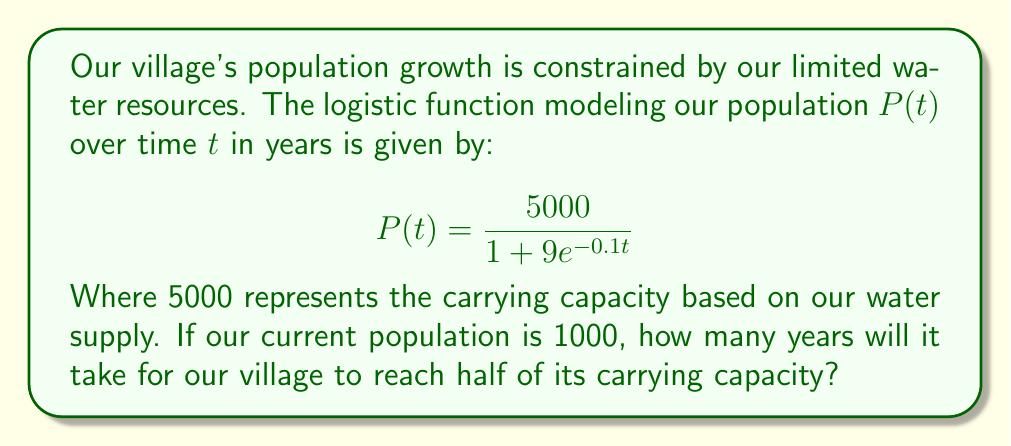Can you solve this math problem? 1) The carrying capacity is 5000, so we want to find when $P(t) = 2500$.

2) Set up the equation:
   $$2500 = \frac{5000}{1 + 9e^{-0.1t}}$$

3) Multiply both sides by $(1 + 9e^{-0.1t})$:
   $$2500(1 + 9e^{-0.1t}) = 5000$$

4) Distribute on the left side:
   $$2500 + 22500e^{-0.1t} = 5000$$

5) Subtract 2500 from both sides:
   $$22500e^{-0.1t} = 2500$$

6) Divide both sides by 22500:
   $$e^{-0.1t} = \frac{1}{9}$$

7) Take the natural log of both sides:
   $$-0.1t = \ln(\frac{1}{9})$$

8) Divide both sides by -0.1:
   $$t = -10\ln(\frac{1}{9}) = 10\ln(9) \approx 21.97$$

Therefore, it will take approximately 22 years for the village to reach half of its carrying capacity.
Answer: 22 years 